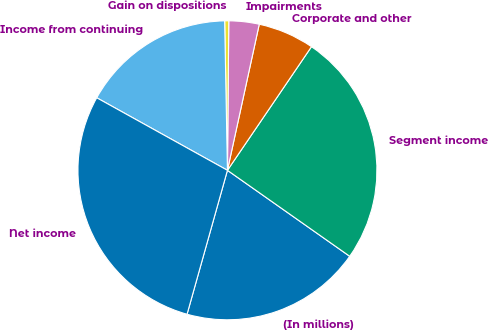<chart> <loc_0><loc_0><loc_500><loc_500><pie_chart><fcel>(In millions)<fcel>Segment income<fcel>Corporate and other<fcel>Impairments<fcel>Gain on dispositions<fcel>Income from continuing<fcel>Net income<nl><fcel>19.6%<fcel>25.25%<fcel>6.09%<fcel>3.27%<fcel>0.44%<fcel>16.64%<fcel>28.71%<nl></chart> 